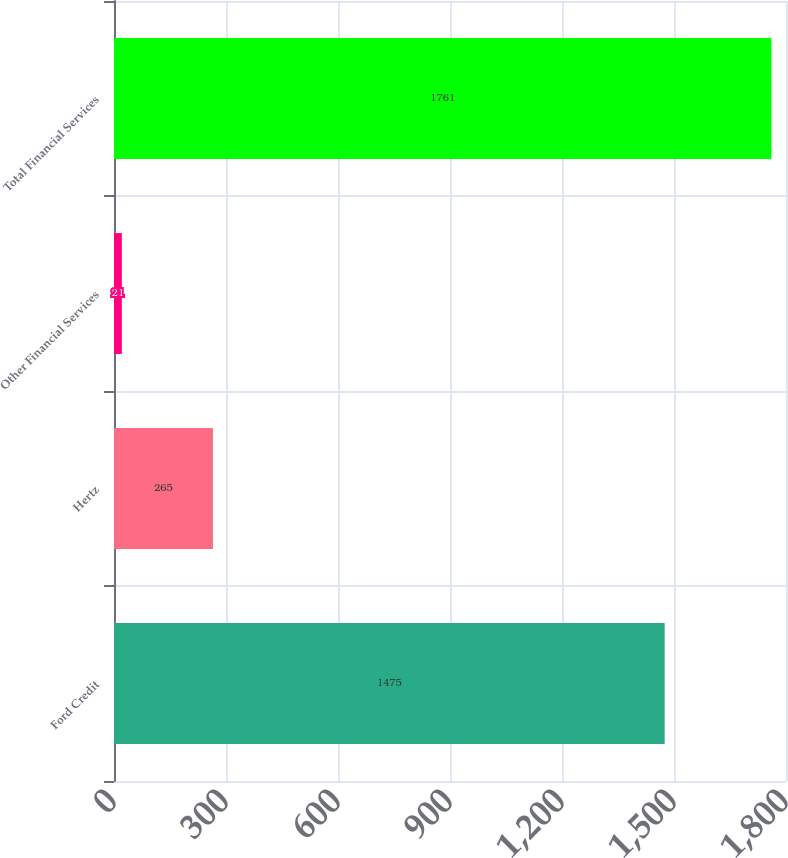<chart> <loc_0><loc_0><loc_500><loc_500><bar_chart><fcel>Ford Credit<fcel>Hertz<fcel>Other Financial Services<fcel>Total Financial Services<nl><fcel>1475<fcel>265<fcel>21<fcel>1761<nl></chart> 